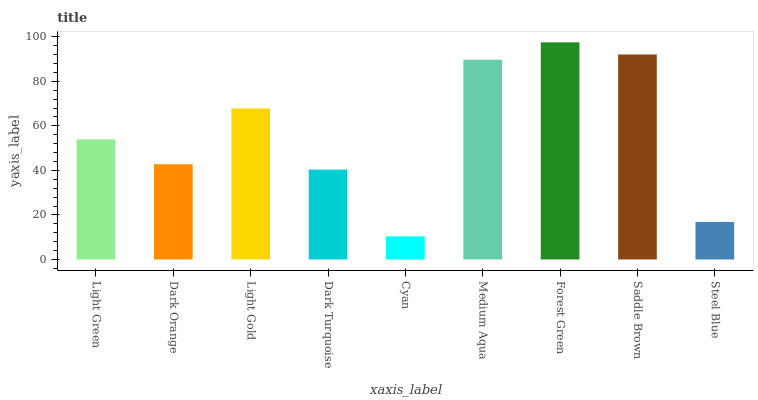Is Cyan the minimum?
Answer yes or no. Yes. Is Forest Green the maximum?
Answer yes or no. Yes. Is Dark Orange the minimum?
Answer yes or no. No. Is Dark Orange the maximum?
Answer yes or no. No. Is Light Green greater than Dark Orange?
Answer yes or no. Yes. Is Dark Orange less than Light Green?
Answer yes or no. Yes. Is Dark Orange greater than Light Green?
Answer yes or no. No. Is Light Green less than Dark Orange?
Answer yes or no. No. Is Light Green the high median?
Answer yes or no. Yes. Is Light Green the low median?
Answer yes or no. Yes. Is Dark Orange the high median?
Answer yes or no. No. Is Dark Turquoise the low median?
Answer yes or no. No. 